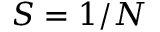Convert formula to latex. <formula><loc_0><loc_0><loc_500><loc_500>S = 1 / N</formula> 